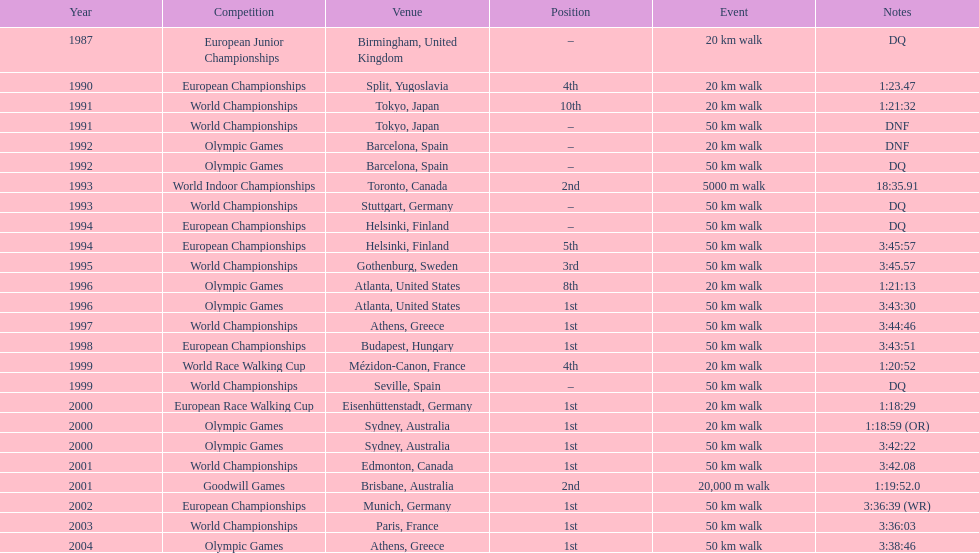What was the distinction in korzeniowski's performance during the 20 km walk event at the 1996 and 2000 olympic games? 2:14. 